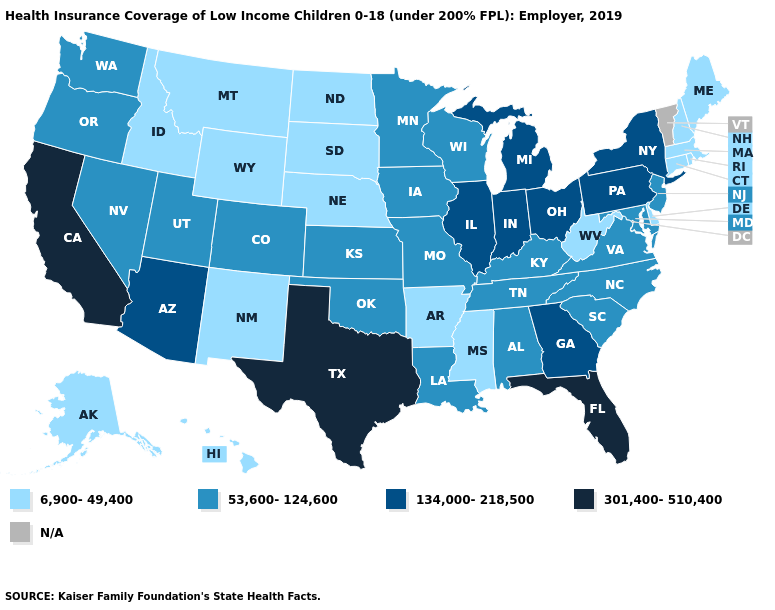Among the states that border Indiana , does Michigan have the highest value?
Be succinct. Yes. What is the value of North Dakota?
Give a very brief answer. 6,900-49,400. What is the value of Maine?
Answer briefly. 6,900-49,400. Name the states that have a value in the range 53,600-124,600?
Answer briefly. Alabama, Colorado, Iowa, Kansas, Kentucky, Louisiana, Maryland, Minnesota, Missouri, Nevada, New Jersey, North Carolina, Oklahoma, Oregon, South Carolina, Tennessee, Utah, Virginia, Washington, Wisconsin. What is the value of Illinois?
Write a very short answer. 134,000-218,500. What is the lowest value in the USA?
Answer briefly. 6,900-49,400. What is the value of Wisconsin?
Answer briefly. 53,600-124,600. What is the value of Maine?
Keep it brief. 6,900-49,400. What is the highest value in states that border Georgia?
Concise answer only. 301,400-510,400. Among the states that border Connecticut , does Massachusetts have the highest value?
Write a very short answer. No. Does Maine have the lowest value in the USA?
Keep it brief. Yes. What is the highest value in the USA?
Keep it brief. 301,400-510,400. What is the value of Minnesota?
Answer briefly. 53,600-124,600. Among the states that border Colorado , which have the lowest value?
Quick response, please. Nebraska, New Mexico, Wyoming. 